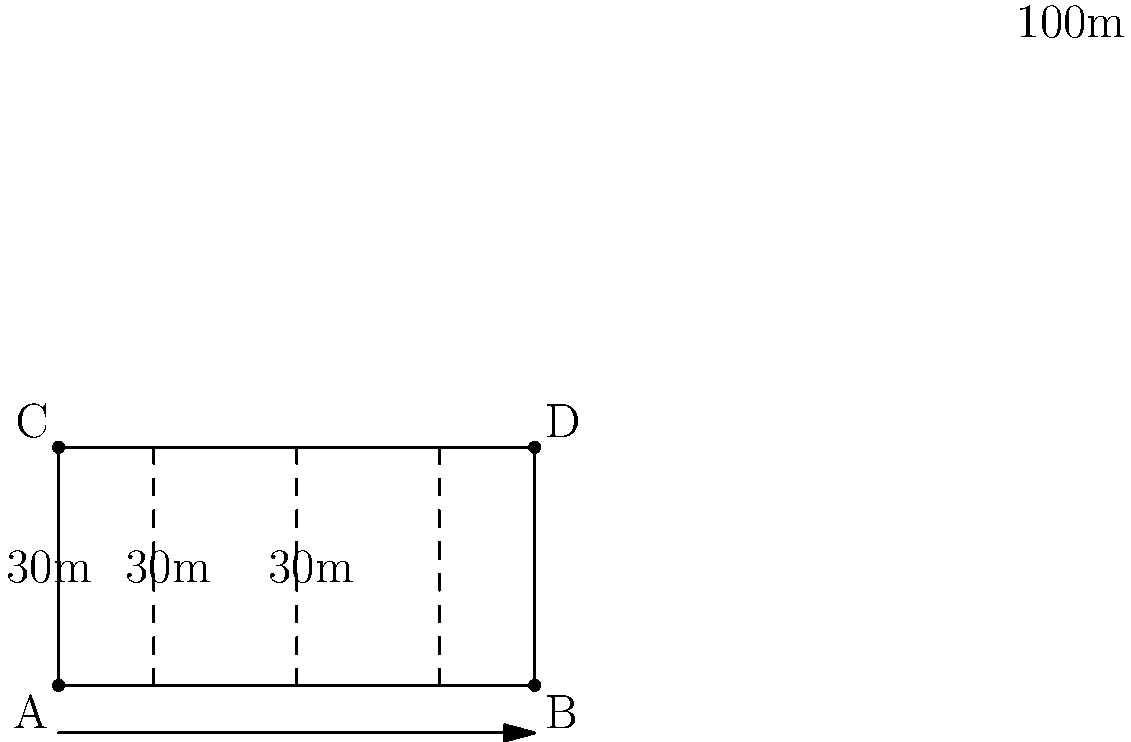In a speedway track design, the starting gates need to be equally spaced. The track is 100 meters long and 50 meters wide. If there are 4 starting gates, including one at each end of the track, what is the optimal distance between each gate? To solve this problem, we need to follow these steps:

1) First, we need to understand that there will be 3 spaces between the 4 gates, as the first and last gates are at the ends of the track.

2) The total length of the track is 100 meters.

3) We need to divide this length into 3 equal parts.

4) Mathematically, this can be expressed as:
   $$\text{Distance between gates} = \frac{\text{Total length}}{\text{Number of spaces}}$$

5) Substituting the values:
   $$\text{Distance} = \frac{100\text{ m}}{3} = 33.33\text{ m}$$

6) Therefore, the optimal distance between each gate is 33.33 meters (rounded to two decimal places).

This spacing ensures that all riders have an equal amount of track in front of them at the start, which is crucial for fair competition in speedway racing.
Answer: 33.33 meters 